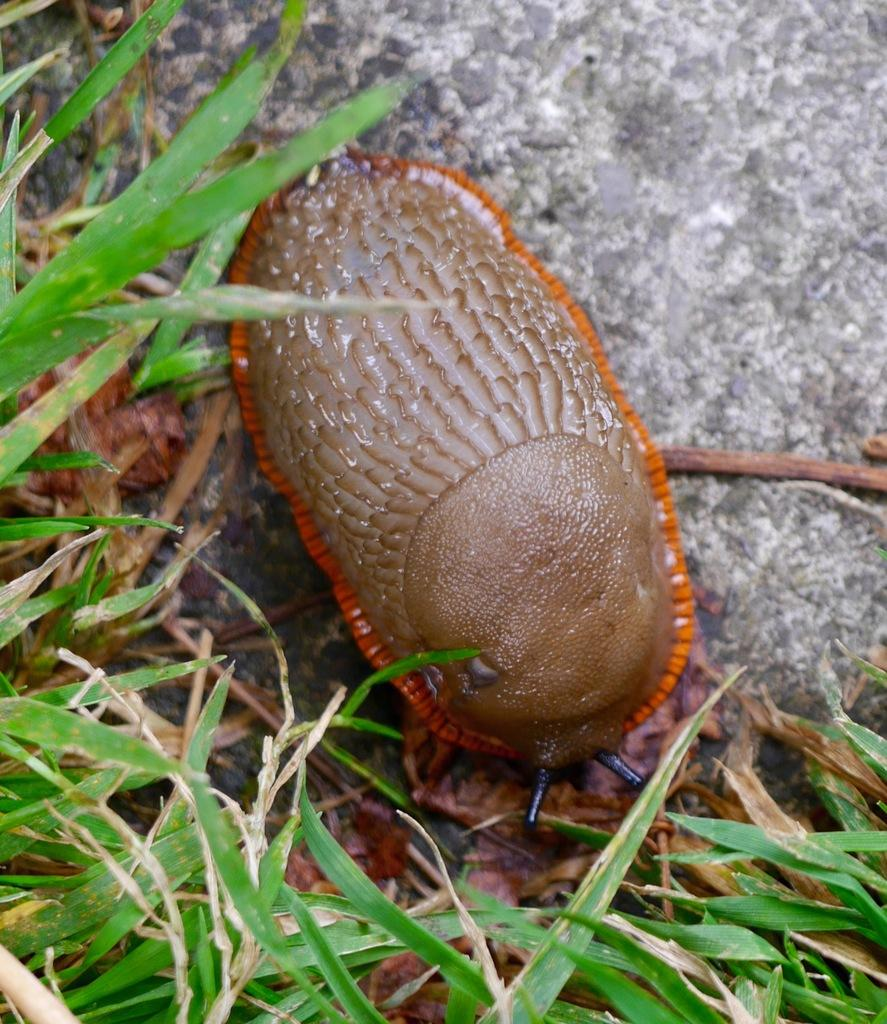What is the main subject in the middle of the image? There is an insect in the middle of the image. What type of vegetation is present at the bottom of the image? There is grass at the bottom of the image. What kind of object can be seen towards the right side of the image? There is a rock-like object towards the right side of the image. What is the name of the insect's son in the image? There is no indication of an insect having a son in the image, as it only shows an insect and no other living creatures. 